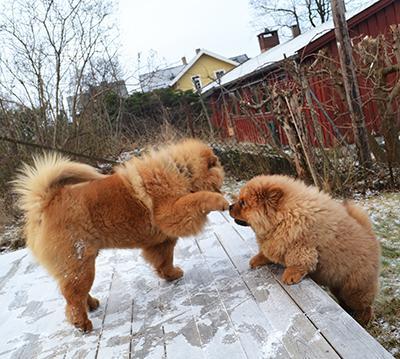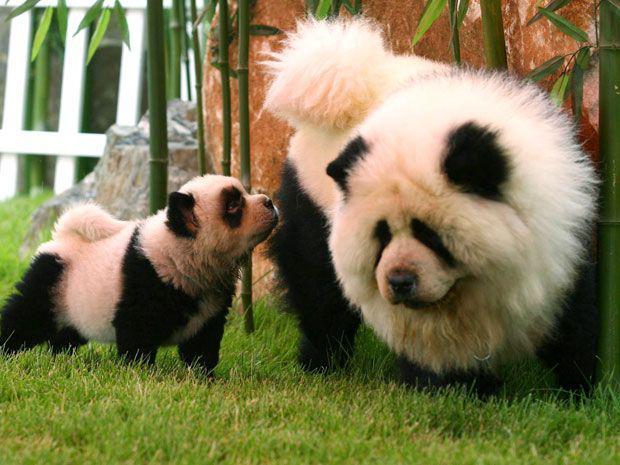The first image is the image on the left, the second image is the image on the right. For the images displayed, is the sentence "One dog in the image on the left is jumping up onto another dog." factually correct? Answer yes or no. No. The first image is the image on the left, the second image is the image on the right. Examine the images to the left and right. Is the description "One of the images shows only one dog." accurate? Answer yes or no. No. 